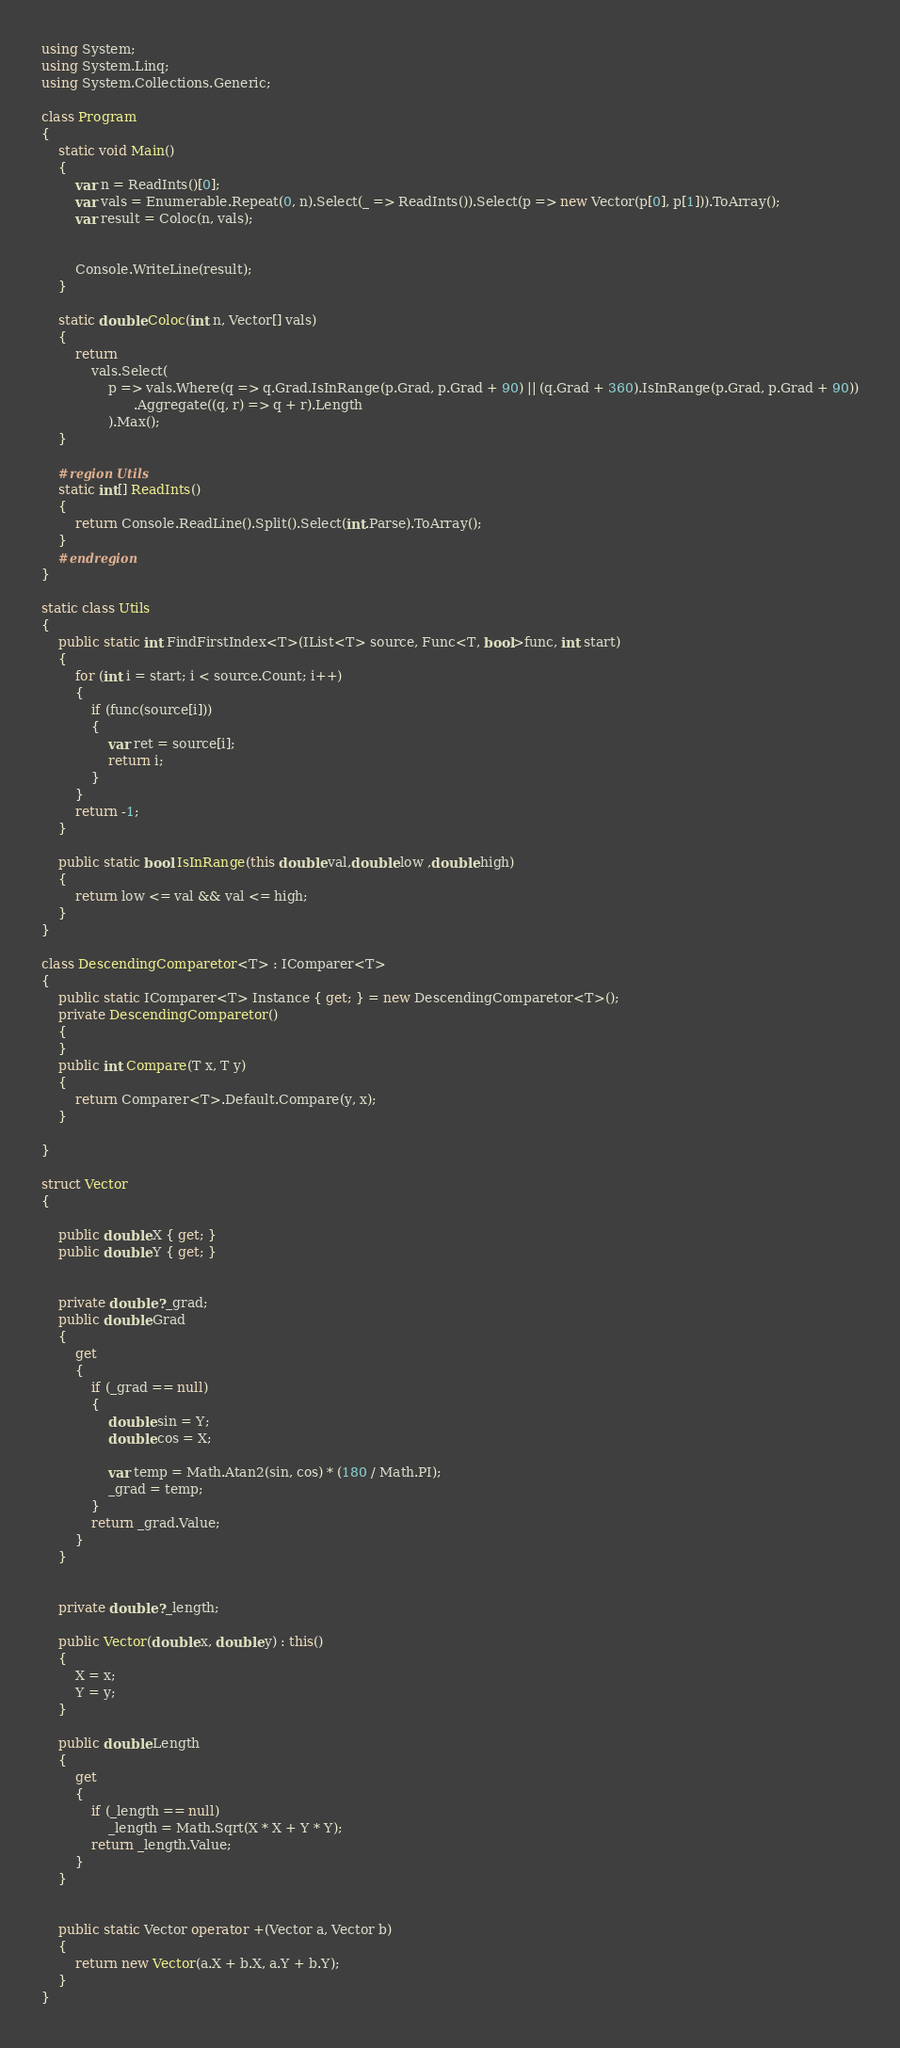Convert code to text. <code><loc_0><loc_0><loc_500><loc_500><_C#_>using System;
using System.Linq;
using System.Collections.Generic;

class Program
{
    static void Main()
    {
        var n = ReadInts()[0];
        var vals = Enumerable.Repeat(0, n).Select(_ => ReadInts()).Select(p => new Vector(p[0], p[1])).ToArray();
        var result = Coloc(n, vals);


        Console.WriteLine(result);
    }

    static double Coloc(int n, Vector[] vals)
    {
        return
            vals.Select(
                p => vals.Where(q => q.Grad.IsInRange(p.Grad, p.Grad + 90) || (q.Grad + 360).IsInRange(p.Grad, p.Grad + 90))
                      .Aggregate((q, r) => q + r).Length
                ).Max();
    }

    #region Utils
    static int[] ReadInts()
    {
        return Console.ReadLine().Split().Select(int.Parse).ToArray();
    }
    #endregion
}

static class Utils
{
    public static int FindFirstIndex<T>(IList<T> source, Func<T, bool>func, int start)
    {
        for (int i = start; i < source.Count; i++)
        {
            if (func(source[i]))
            {
                var ret = source[i];
                return i;
            }
        }
        return -1;
    }

    public static bool IsInRange(this double val,double low ,double high)
    {
        return low <= val && val <= high;
    }
}

class DescendingComparetor<T> : IComparer<T>
{
    public static IComparer<T> Instance { get; } = new DescendingComparetor<T>();
    private DescendingComparetor()
    {
    }
    public int Compare(T x, T y)
    {
        return Comparer<T>.Default.Compare(y, x);
    }

}

struct Vector
{

    public double X { get; }
    public double Y { get; }


    private double? _grad;
    public double Grad
    {
        get
        {
            if (_grad == null)
            {
                double sin = Y;
                double cos = X;

                var temp = Math.Atan2(sin, cos) * (180 / Math.PI);
                _grad = temp;
            }
            return _grad.Value;
        }
    }


    private double? _length;

    public Vector(double x, double y) : this()
    {
        X = x;
        Y = y;
    }

    public double Length
    {
        get
        {
            if (_length == null)
                _length = Math.Sqrt(X * X + Y * Y);
            return _length.Value;
        }
    }


    public static Vector operator +(Vector a, Vector b)
    {
        return new Vector(a.X + b.X, a.Y + b.Y);
    }
}</code> 